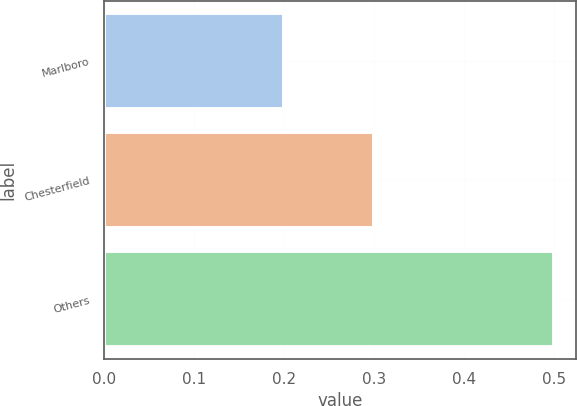Convert chart. <chart><loc_0><loc_0><loc_500><loc_500><bar_chart><fcel>Marlboro<fcel>Chesterfield<fcel>Others<nl><fcel>0.2<fcel>0.3<fcel>0.5<nl></chart> 